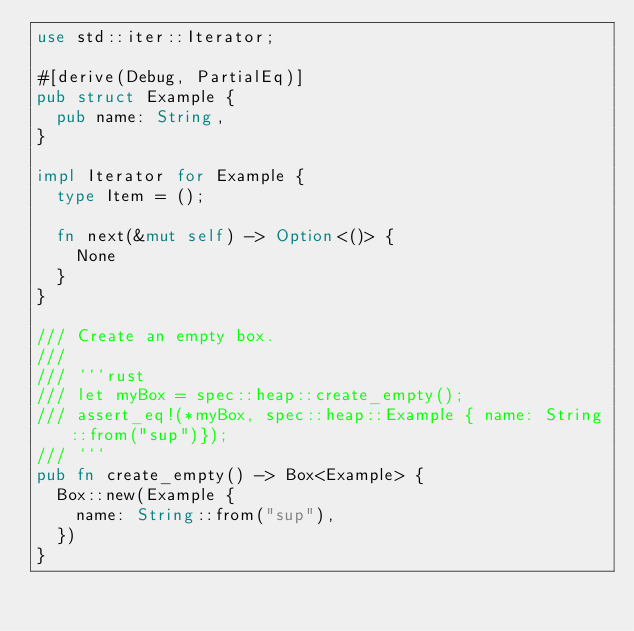Convert code to text. <code><loc_0><loc_0><loc_500><loc_500><_Rust_>use std::iter::Iterator;

#[derive(Debug, PartialEq)]
pub struct Example {
  pub name: String,
}

impl Iterator for Example {
  type Item = ();

  fn next(&mut self) -> Option<()> {
    None
  }
}

/// Create an empty box.
///
/// ```rust
/// let myBox = spec::heap::create_empty();
/// assert_eq!(*myBox, spec::heap::Example { name: String::from("sup")});
/// ```
pub fn create_empty() -> Box<Example> {
  Box::new(Example {
    name: String::from("sup"),
  })
}
</code> 